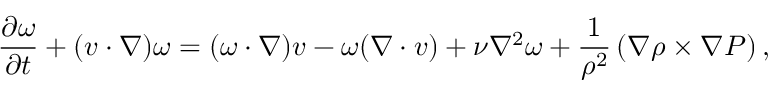<formula> <loc_0><loc_0><loc_500><loc_500>\frac { \partial \omega } { \partial t } + ( v \cdot \nabla ) \omega = ( \omega \cdot \nabla ) v - \omega ( \nabla \cdot v ) + \nu \nabla ^ { 2 } \omega + \frac { 1 } { \rho ^ { 2 } } \left ( \nabla \rho \times \nabla P \right ) ,</formula> 